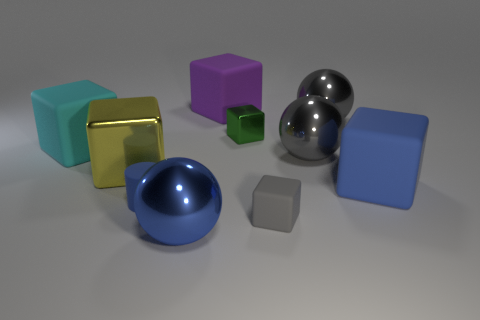Subtract all big purple blocks. How many blocks are left? 5 Subtract all green cubes. How many cubes are left? 5 Subtract all cyan cylinders. How many gray spheres are left? 2 Subtract all cylinders. How many objects are left? 9 Subtract 1 balls. How many balls are left? 2 Subtract all cyan blocks. Subtract all purple cubes. How many objects are left? 8 Add 6 big balls. How many big balls are left? 9 Add 1 gray metal objects. How many gray metal objects exist? 3 Subtract 1 blue spheres. How many objects are left? 9 Subtract all cyan cylinders. Subtract all brown balls. How many cylinders are left? 1 